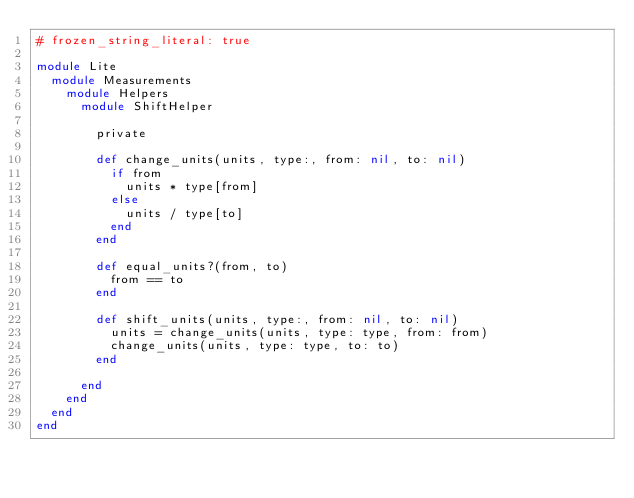<code> <loc_0><loc_0><loc_500><loc_500><_Ruby_># frozen_string_literal: true

module Lite
  module Measurements
    module Helpers
      module ShiftHelper

        private

        def change_units(units, type:, from: nil, to: nil)
          if from
            units * type[from]
          else
            units / type[to]
          end
        end

        def equal_units?(from, to)
          from == to
        end

        def shift_units(units, type:, from: nil, to: nil)
          units = change_units(units, type: type, from: from)
          change_units(units, type: type, to: to)
        end

      end
    end
  end
end
</code> 